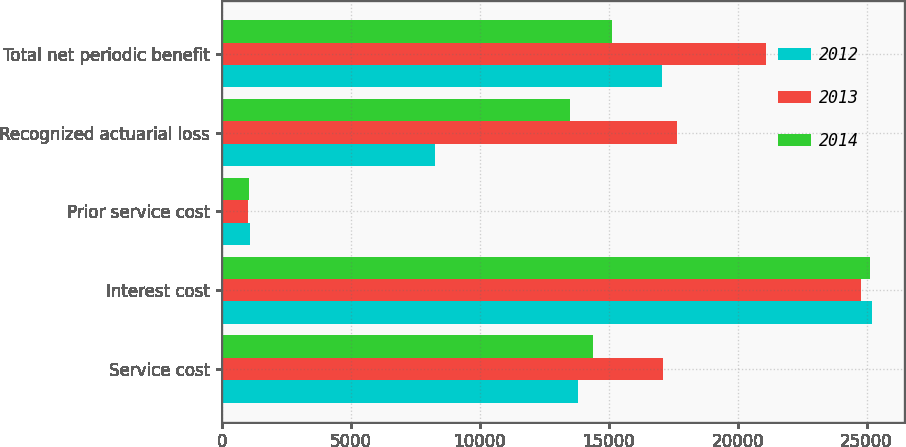<chart> <loc_0><loc_0><loc_500><loc_500><stacked_bar_chart><ecel><fcel>Service cost<fcel>Interest cost<fcel>Prior service cost<fcel>Recognized actuarial loss<fcel>Total net periodic benefit<nl><fcel>2012<fcel>13801<fcel>25204<fcel>1083<fcel>8289<fcel>17062<nl><fcel>2013<fcel>17123<fcel>24801<fcel>1026<fcel>17654<fcel>21098<nl><fcel>2014<fcel>14406<fcel>25136<fcel>1048<fcel>13515<fcel>15127<nl></chart> 